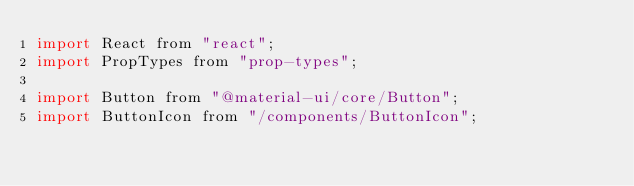Convert code to text. <code><loc_0><loc_0><loc_500><loc_500><_JavaScript_>import React from "react";
import PropTypes from "prop-types";

import Button from "@material-ui/core/Button";
import ButtonIcon from "/components/ButtonIcon";</code> 